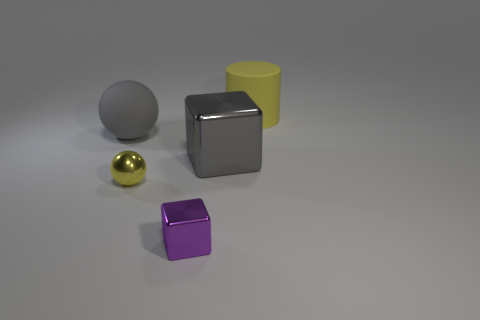What is the texture of the surface that the objects are resting on? The objects are resting on a matte surface that seems slightly uneven with a gentle gradient of light, giving it a realistic appearance typical of a neutral, non-reflective material.  Does the lighting in the image suggest a particular time of day? The lighting in the image does not necessarily suggest a specific time of day as it appears to be a controlled, studio-like setting. The even lighting minimizes shadows and is commonly used in product photography. 